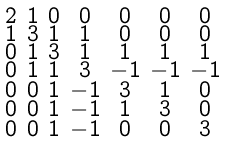<formula> <loc_0><loc_0><loc_500><loc_500>\begin{smallmatrix} 2 & 1 & 0 & 0 & 0 & 0 & 0 \\ 1 & 3 & 1 & 1 & 0 & 0 & 0 \\ 0 & 1 & 3 & 1 & 1 & 1 & 1 \\ 0 & 1 & 1 & 3 & - 1 & - 1 & - 1 \\ 0 & 0 & 1 & - 1 & 3 & 1 & 0 \\ 0 & 0 & 1 & - 1 & 1 & 3 & 0 \\ 0 & 0 & 1 & - 1 & 0 & 0 & 3 \end{smallmatrix}</formula> 